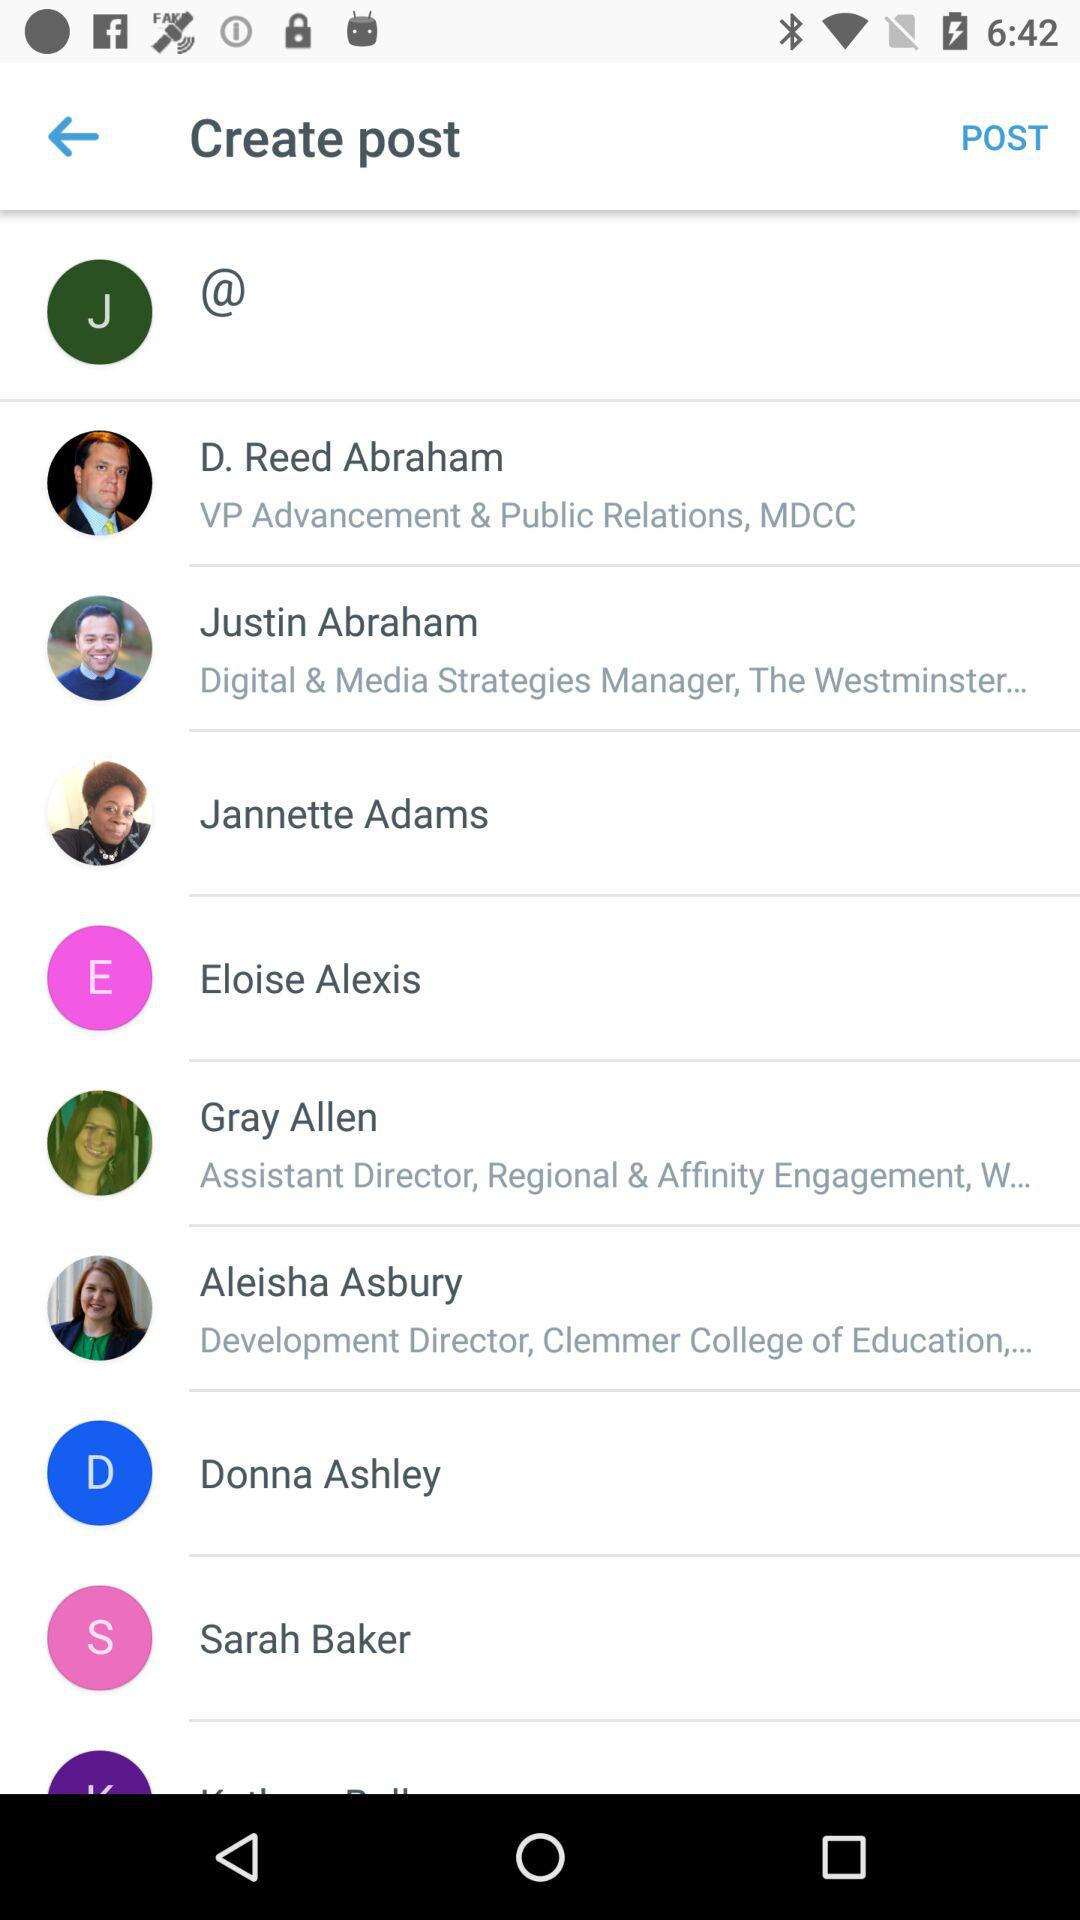Who is the assistant director for regional and affinity engagement? The assistant director for regional and affinity engagement is Gray Allen. 